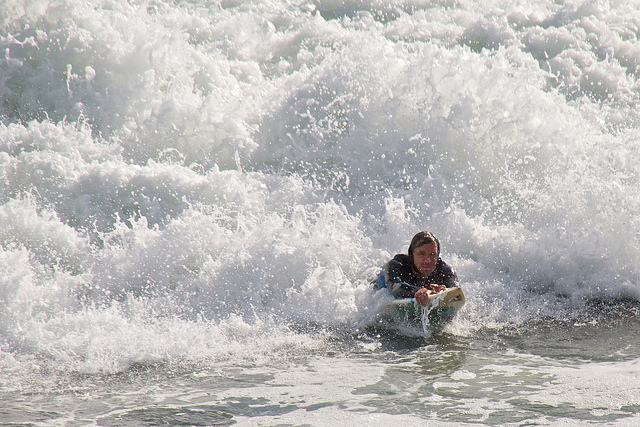What kind of water activity is depicted in the image? The image shows a person engaged in surfing, riding the crest of a wave. 